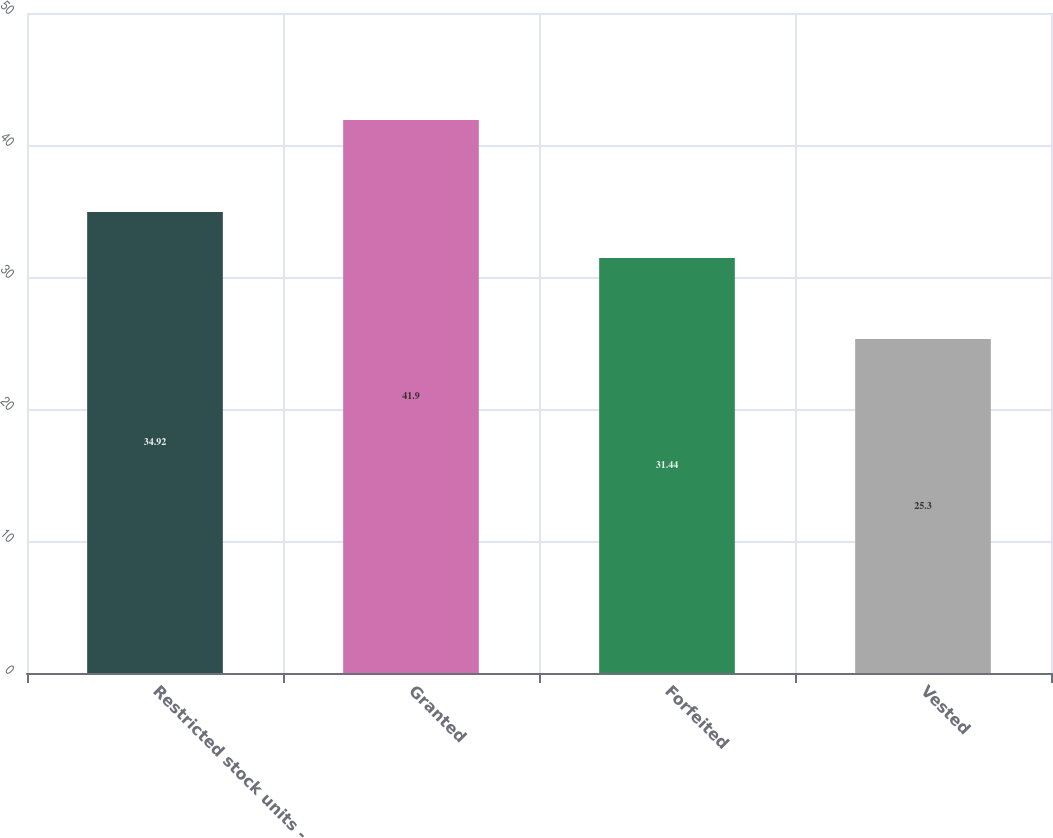Convert chart. <chart><loc_0><loc_0><loc_500><loc_500><bar_chart><fcel>Restricted stock units -<fcel>Granted<fcel>Forfeited<fcel>Vested<nl><fcel>34.92<fcel>41.9<fcel>31.44<fcel>25.3<nl></chart> 